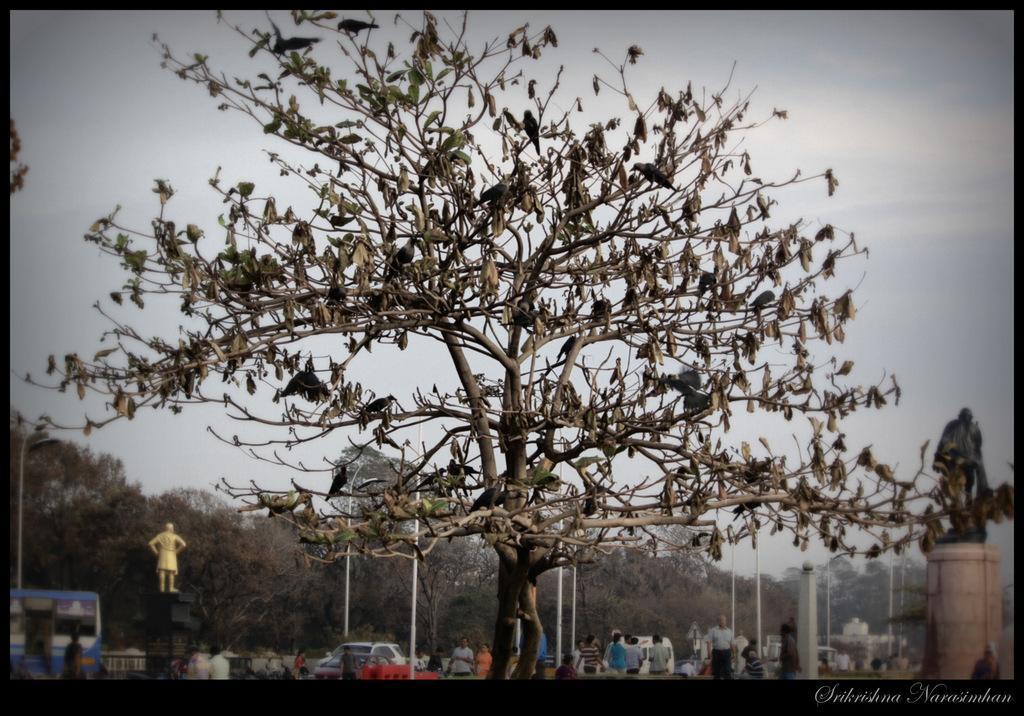Can you describe this image briefly? In this image there is a tree in the middle. On the tree there are so many birds. On the left side there is a statue, Beside the statue there is a bus. At the top there is the sky. On the right side there is another statue. In the background there are few people walking on the road. Beside them there are poles and vehicles. 